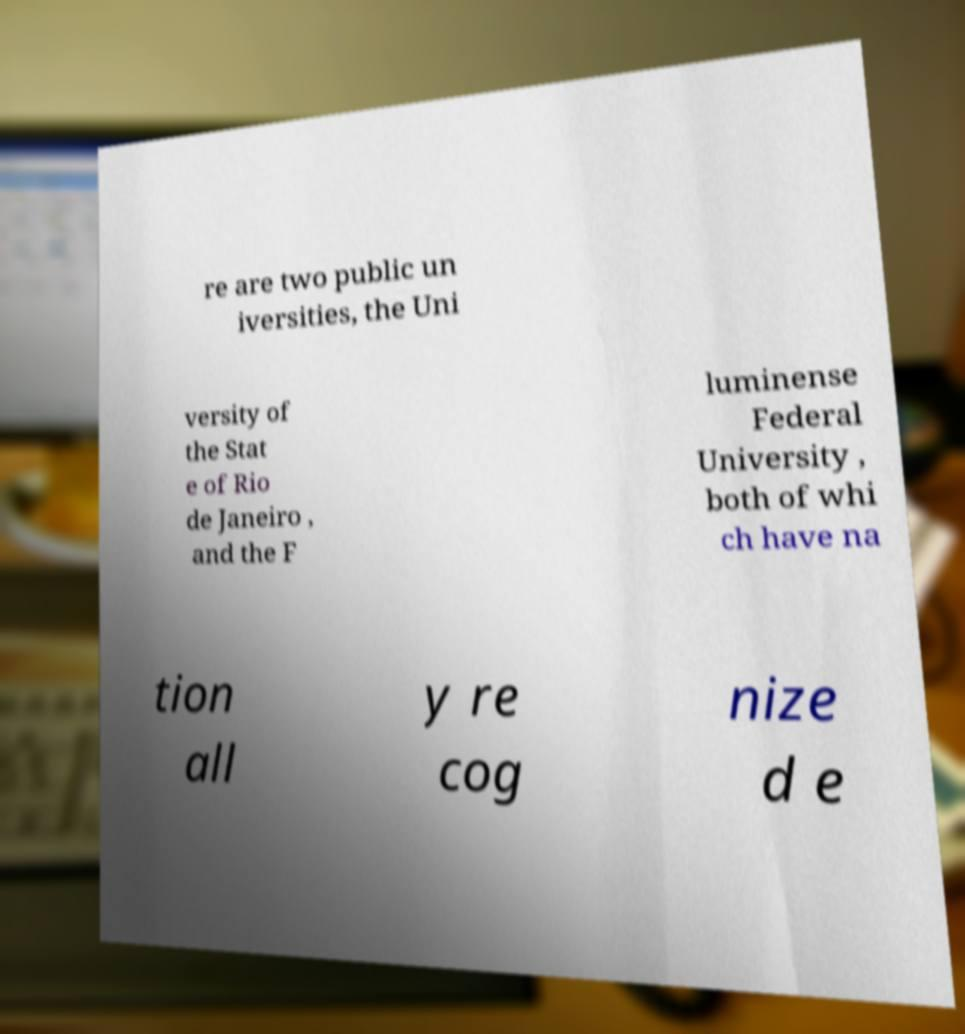Can you read and provide the text displayed in the image?This photo seems to have some interesting text. Can you extract and type it out for me? re are two public un iversities, the Uni versity of the Stat e of Rio de Janeiro , and the F luminense Federal University , both of whi ch have na tion all y re cog nize d e 